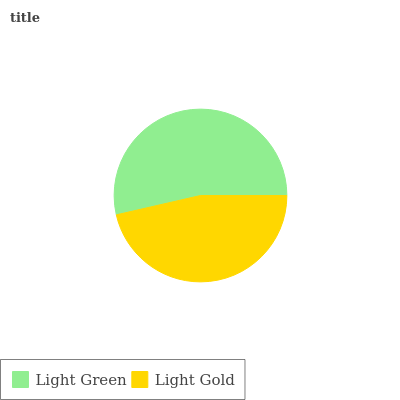Is Light Gold the minimum?
Answer yes or no. Yes. Is Light Green the maximum?
Answer yes or no. Yes. Is Light Gold the maximum?
Answer yes or no. No. Is Light Green greater than Light Gold?
Answer yes or no. Yes. Is Light Gold less than Light Green?
Answer yes or no. Yes. Is Light Gold greater than Light Green?
Answer yes or no. No. Is Light Green less than Light Gold?
Answer yes or no. No. Is Light Green the high median?
Answer yes or no. Yes. Is Light Gold the low median?
Answer yes or no. Yes. Is Light Gold the high median?
Answer yes or no. No. Is Light Green the low median?
Answer yes or no. No. 